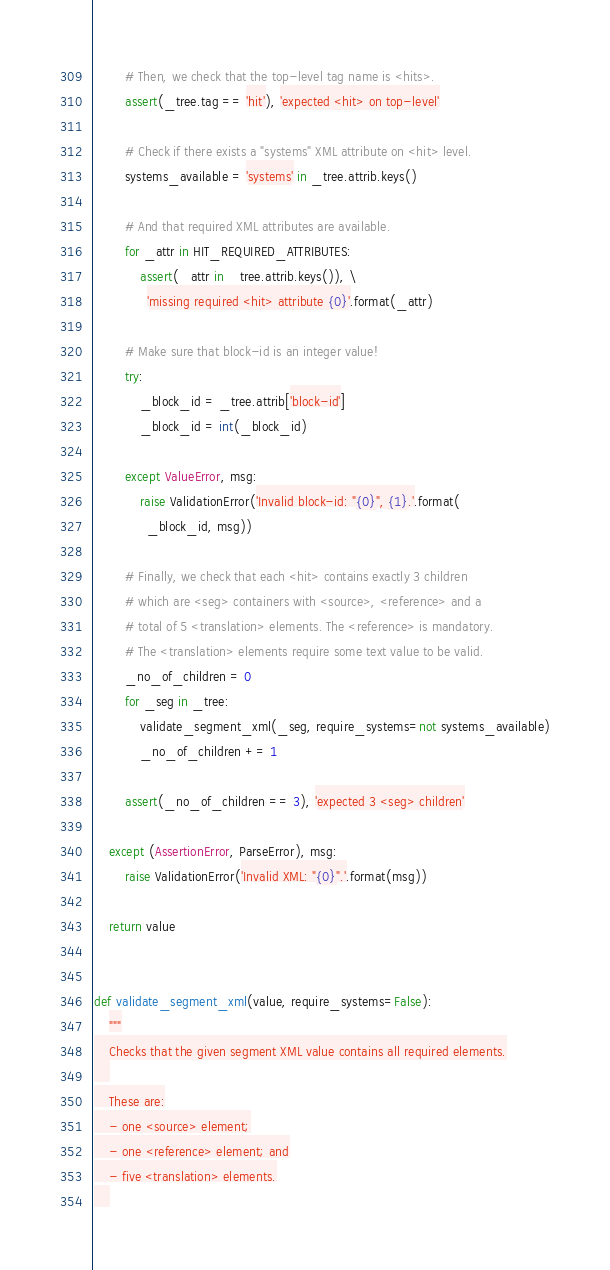Convert code to text. <code><loc_0><loc_0><loc_500><loc_500><_Python_>        # Then, we check that the top-level tag name is <hits>.
        assert(_tree.tag == 'hit'), 'expected <hit> on top-level'
        
        # Check if there exists a "systems" XML attribute on <hit> level.
        systems_available = 'systems' in _tree.attrib.keys()
        
        # And that required XML attributes are available.
        for _attr in HIT_REQUIRED_ATTRIBUTES:
            assert(_attr in _tree.attrib.keys()), \
              'missing required <hit> attribute {0}'.format(_attr)
        
        # Make sure that block-id is an integer value!
        try:
            _block_id = _tree.attrib['block-id']
            _block_id = int(_block_id)
        
        except ValueError, msg:
            raise ValidationError('Invalid block-id: "{0}", {1}.'.format(
              _block_id, msg))
        
        # Finally, we check that each <hit> contains exactly 3 children
        # which are <seg> containers with <source>, <reference> and a
        # total of 5 <translation> elements. The <reference> is mandatory.
        # The <translation> elements require some text value to be valid.
        _no_of_children = 0
        for _seg in _tree:
            validate_segment_xml(_seg, require_systems=not systems_available)
            _no_of_children += 1
        
        assert(_no_of_children == 3), 'expected 3 <seg> children'
    
    except (AssertionError, ParseError), msg:
        raise ValidationError('Invalid XML: "{0}".'.format(msg))
    
    return value


def validate_segment_xml(value, require_systems=False):
    """
    Checks that the given segment XML value contains all required elements.
    
    These are:
    - one <source> element;
    - one <reference> element; and
    - five <translation> elements.
    </code> 